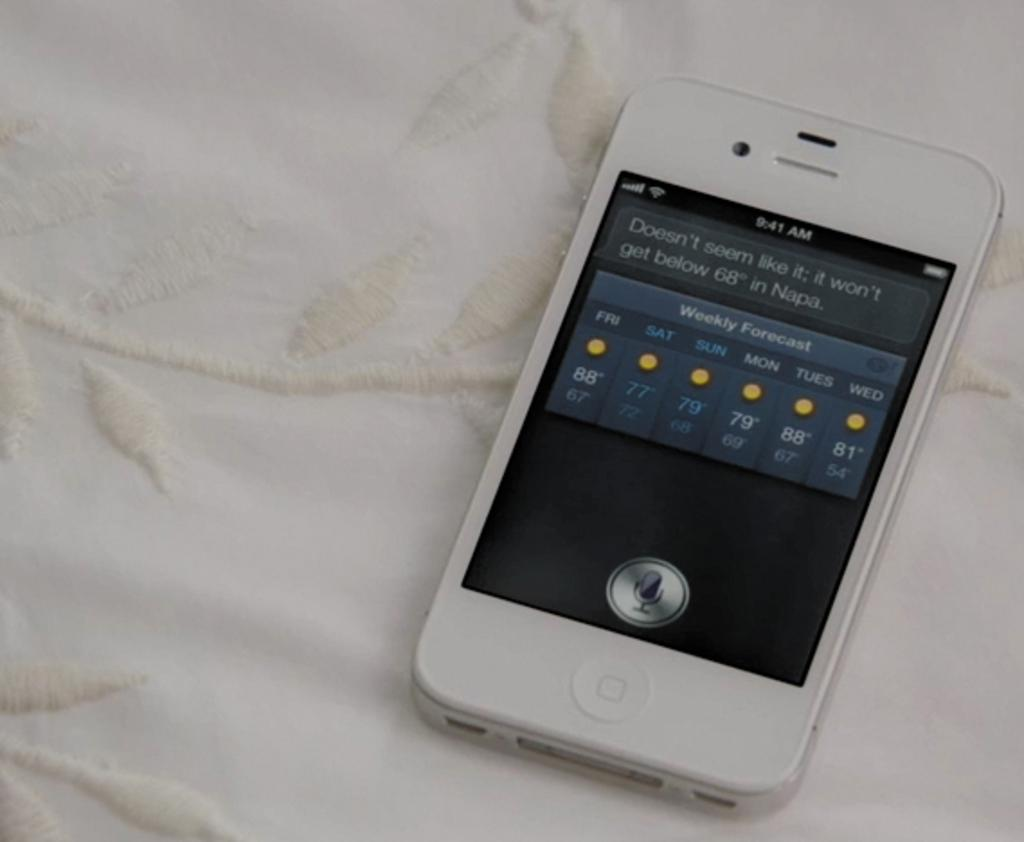<image>
Describe the image concisely. A cell phone with a weather forecast saying 'weekly forecast' 